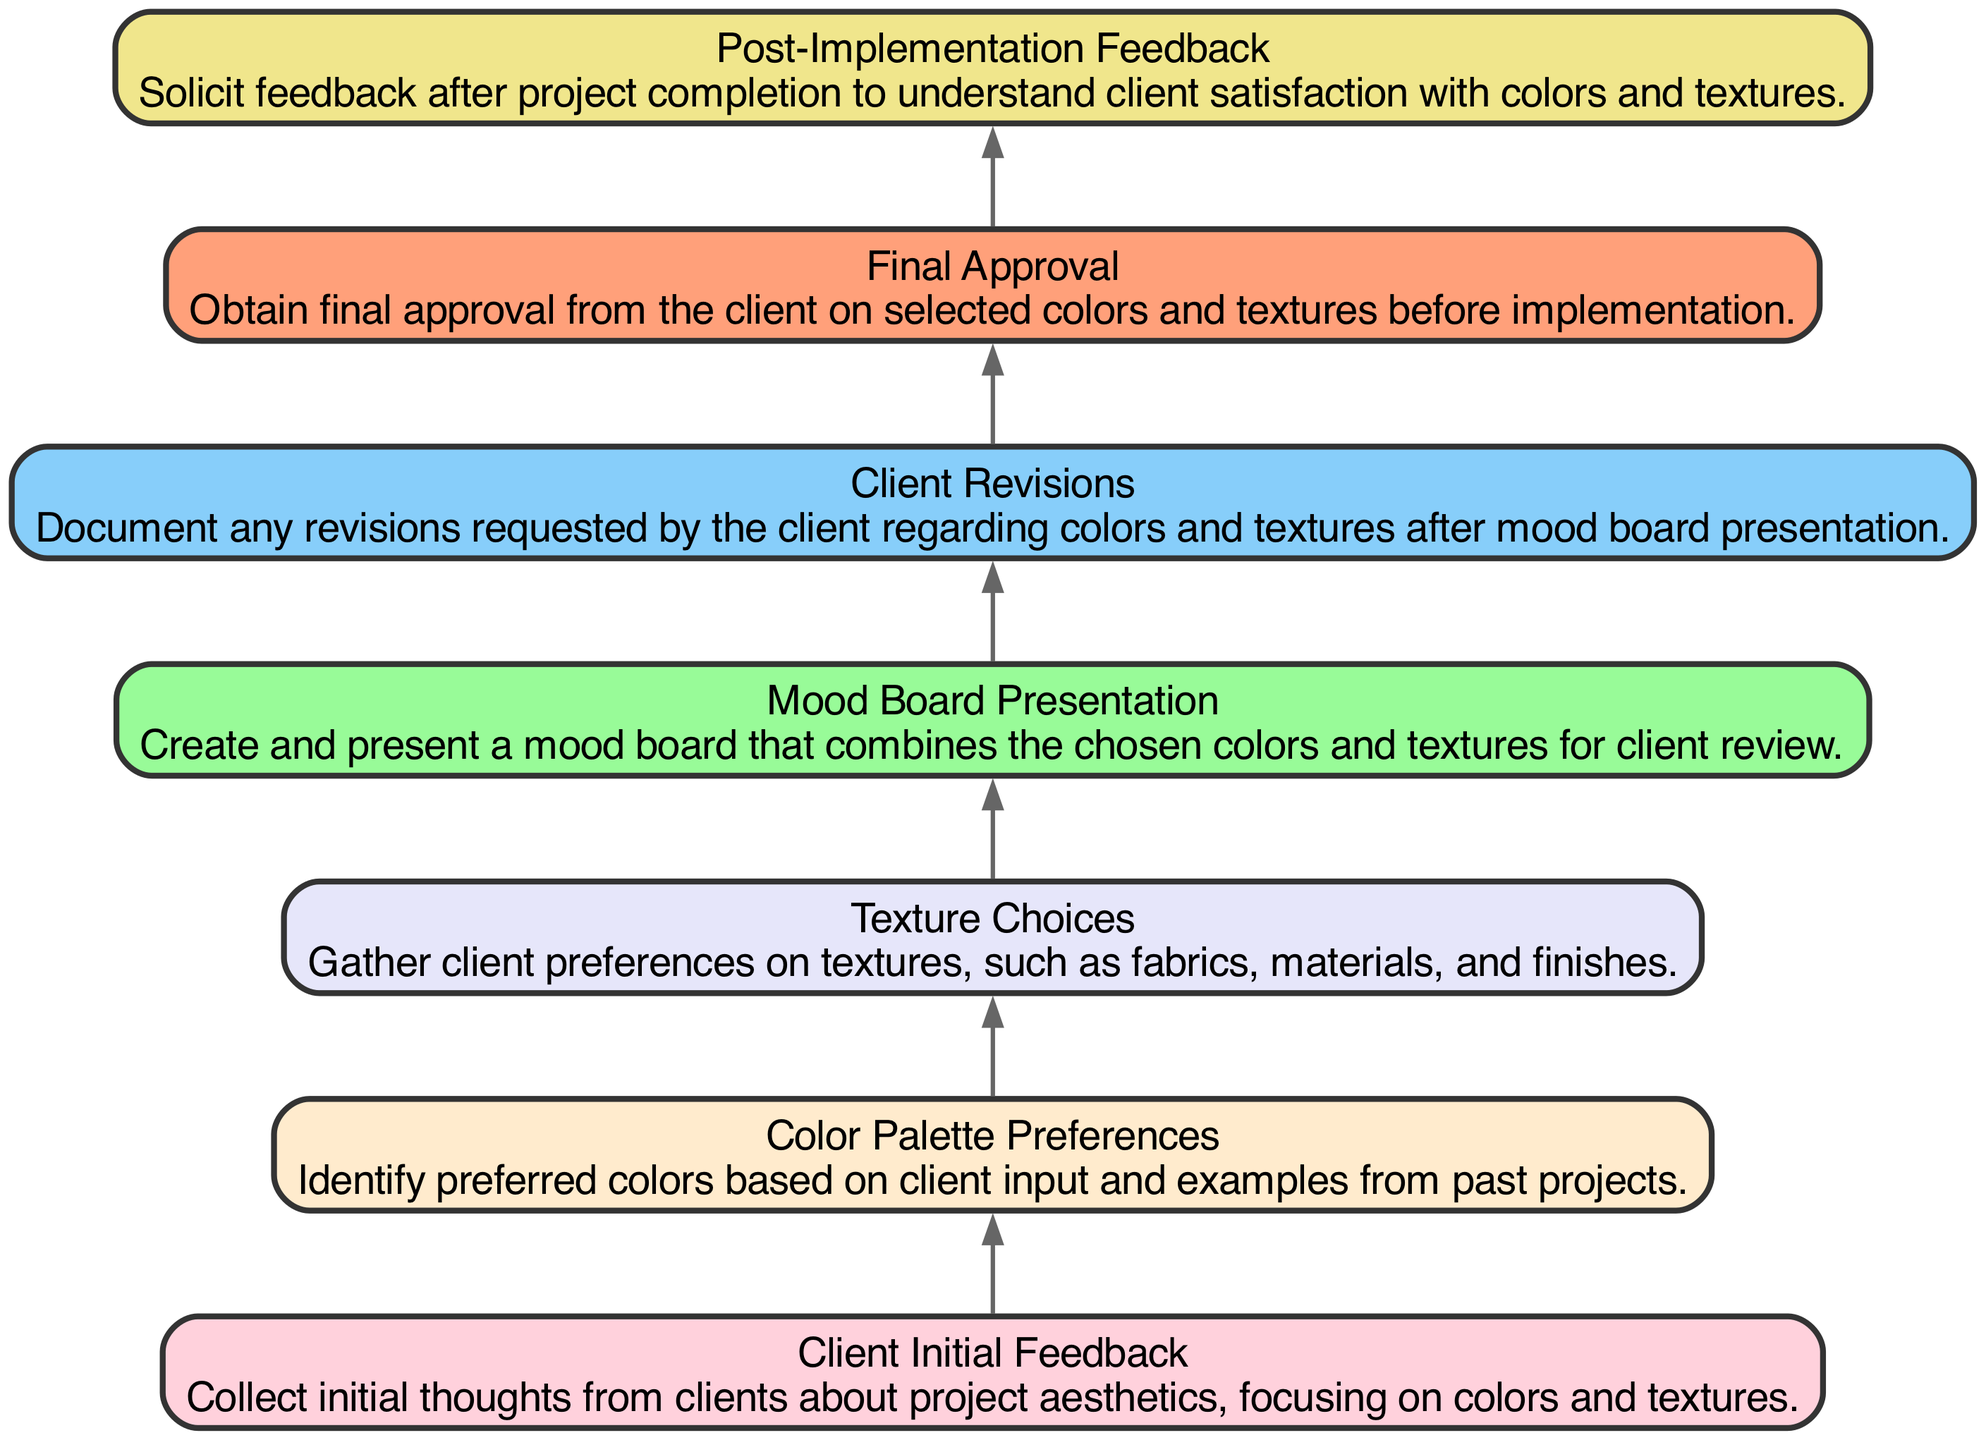What is the first node in the flow chart? The first node listed in the flow chart is "Client Initial Feedback," which is designated as the starting point for the process.
Answer: Client Initial Feedback How many nodes are present in the diagram? The diagram contains a total of 7 nodes, each representing a specific step in the client feedback analysis process related to interior design.
Answer: 7 What is the last step before obtaining the final approval? The step that directly precedes obtaining final approval is "Client Revisions," where any changes requested by the client are documented.
Answer: Client Revisions Which node deals with post-project client satisfaction? The node specifically addressing client satisfaction post-project is "Post-Implementation Feedback," which seeks feedback after the project is completed.
Answer: Post-Implementation Feedback What is the relationship between "Texture Choices" and "Mood Board Presentation"? "Texture Choices" flows directly into "Mood Board Presentation," as the textures selected will be combined with colors to create the mood board for the client's review.
Answer: Direct flow What comes after "Client Initial Feedback"? The node that follows "Client Initial Feedback" is "Color Palette Preferences," indicating a sequential progression in gathering client preferences starting with initial thoughts.
Answer: Color Palette Preferences How many edges are there in the diagram? The number of edges is determined by the connections between nodes, and there are 6 edges that represent transitions between each of the steps in the feedback analysis process.
Answer: 6 Which node is focused on presenting color and texture combinations? The node dedicated to the combination and presentation of colors and textures is "Mood Board Presentation," where a visual representation is shared with the client.
Answer: Mood Board Presentation What is the overall flow direction of the diagram? The overall flow direction in the diagram is from bottom to top (bottom-up), starting from initial feedback and culminating in post-implementation feedback.
Answer: Bottom to top 